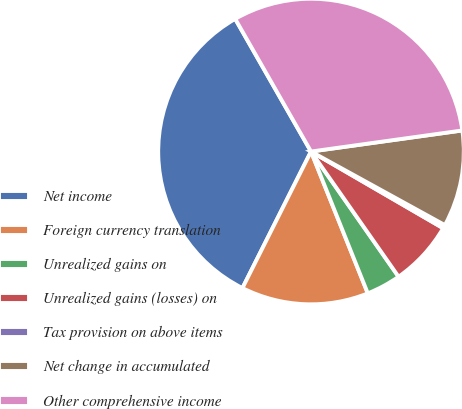<chart> <loc_0><loc_0><loc_500><loc_500><pie_chart><fcel>Net income<fcel>Foreign currency translation<fcel>Unrealized gains on<fcel>Unrealized gains (losses) on<fcel>Tax provision on above items<fcel>Net change in accumulated<fcel>Other comprehensive income<nl><fcel>34.33%<fcel>13.47%<fcel>3.65%<fcel>6.92%<fcel>0.37%<fcel>10.2%<fcel>31.06%<nl></chart> 